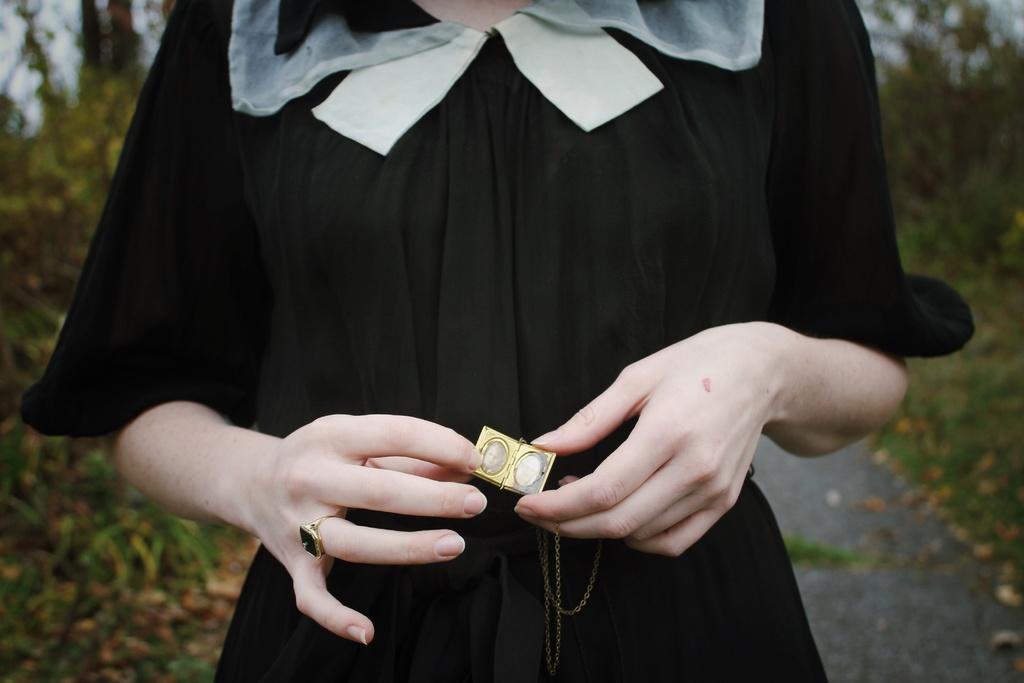Please provide a concise description of this image. In this picture we can observe a woman holding a locket in her hands. She is wearing black color dress. In the background we can observe some plants and trees. 